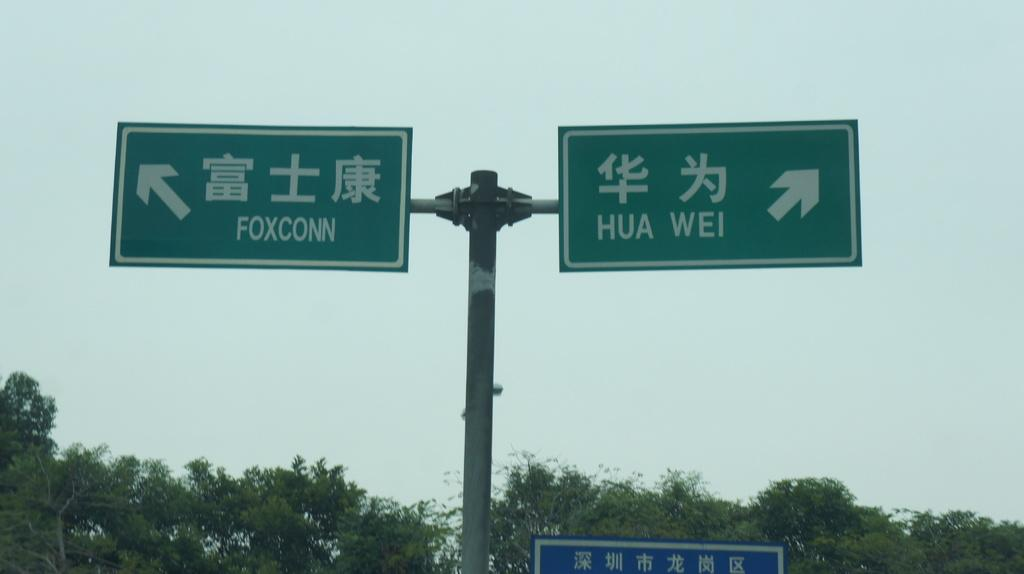<image>
Share a concise interpretation of the image provided. Two green street signs are suspended in the air, with arrows pointing in opposite directions to Foxconn and Hua Wei. 